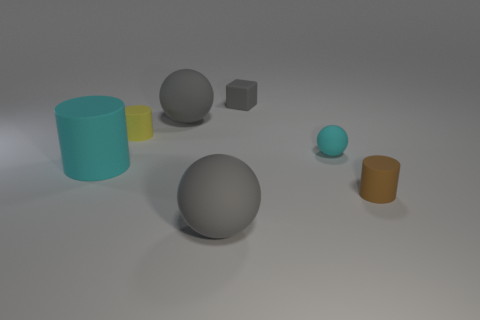The yellow thing is what shape?
Offer a very short reply. Cylinder. Does the large gray thing behind the tiny brown rubber cylinder have the same material as the cylinder that is on the right side of the gray cube?
Provide a short and direct response. Yes. How many matte spheres are the same color as the cube?
Provide a succinct answer. 2. The rubber object that is both behind the small brown object and right of the small gray rubber object has what shape?
Make the answer very short. Sphere. There is a big matte thing that is in front of the yellow cylinder and right of the yellow cylinder; what is its color?
Give a very brief answer. Gray. Are there more large cyan matte things behind the large cylinder than yellow things behind the tiny yellow matte thing?
Give a very brief answer. No. The small matte cube to the right of the yellow matte object is what color?
Offer a very short reply. Gray. Is the shape of the cyan thing on the left side of the yellow cylinder the same as the cyan matte object that is right of the tiny matte cube?
Give a very brief answer. No. Is there a gray rubber object of the same size as the brown rubber thing?
Your answer should be compact. Yes. There is a large ball that is in front of the small yellow rubber object; what is its material?
Make the answer very short. Rubber. 